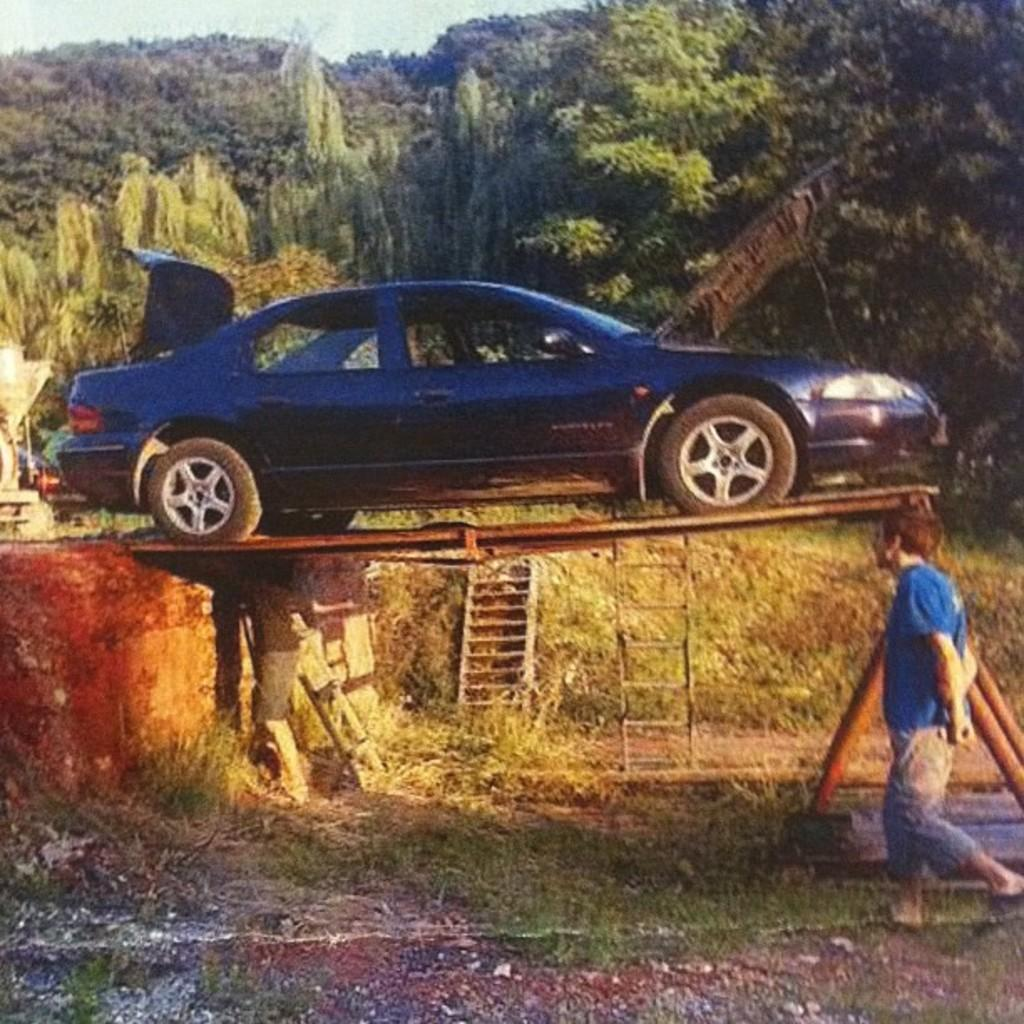What is the main subject in the middle of the image? There is a car in the middle of the image. What is happening on the right side of the image? A man is walking on the right side of the image. What is the man wearing? The man is wearing a blue t-shirt. What can be seen in the background of the image? There are trees visible in the background of the image. How many frogs are jumping across the car in the image? There are no frogs present in the image, so it is not possible to determine how many would be jumping across the car. 